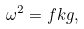Convert formula to latex. <formula><loc_0><loc_0><loc_500><loc_500>\omega ^ { 2 } = f k g ,</formula> 